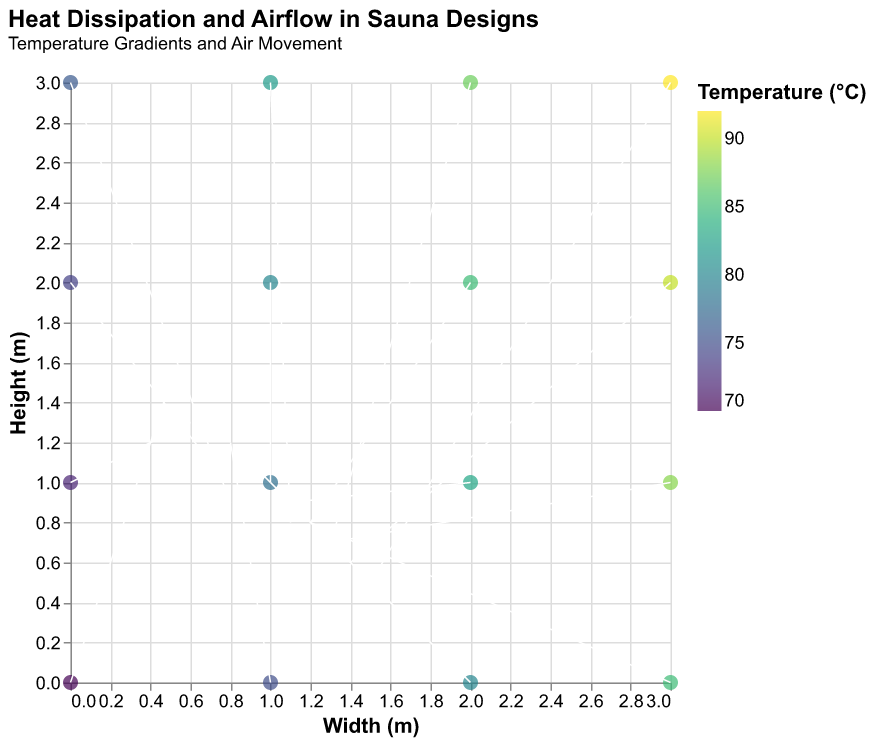What is the title of the figure? The title of the figure appears at the top and reads "Heat Dissipation and Airflow in Sauna Designs".
Answer: Heat Dissipation and Airflow in Sauna Designs Which axis represents width, and which represents height? The x-axis is labeled "Width (m)", and the y-axis is labeled "Height (m)".
Answer: The x-axis represents width, and the y-axis represents height What is the range of temperatures displayed in the figure? By looking at the color legend on the figure, the temperature ranges from 70°C to 92°C.
Answer: 70°C to 92°C How does the temperature vary as you move from (0, 0) to (3, 3)? As you move from (0, 0) to (3, 3), the temperature increases from 70°C to 92°C. This trend can be seen in the color gradient from cooler to warmer colors following this diagonal path.
Answer: Increases from 70°C to 92°C Compare the airflow magnitude at point (1, 1) and (3, 3). Which is higher? At point (1, 1), the vector components u and v are (0.9, 1.1), resulting in a magnitude of sqrt(0.9^2 + 1.1^2) ≈ 1.421. At point (3, 3), the vector components u and v are (1.5, 0.5), resulting in a magnitude of sqrt(1.5^2 + 0.5^2) ≈ 1.581. Therefore, the airflow magnitude at point (3, 3) is higher.
Answer: Airflow at (3, 3) is higher What is the direction of airflow at point (2, 0)? The direction of airflow is indicated by the vector (1.0, 1.0). This vector suggests an upward right diagonal movement from point (2, 0).
Answer: Upward right diagonal Which point has the highest temperature and what is the airflow direction at that point? The highest temperature in the dataset is 92°C at point (3, 3). The airflow direction at this point is indicated by the vector (1.5, 0.5), which suggests an upward right diagonal movement.
Answer: (3, 3), Upward right diagonal 